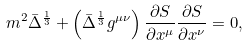<formula> <loc_0><loc_0><loc_500><loc_500>m ^ { 2 } \bar { \Delta } ^ { \frac { 1 } { 3 } } + \left ( \bar { \Delta } ^ { \frac { 1 } { 3 } } g ^ { \mu \nu } \right ) \frac { \partial S } { \partial x ^ { \mu } } \frac { \partial S } { \partial x ^ { \nu } } = 0 ,</formula> 